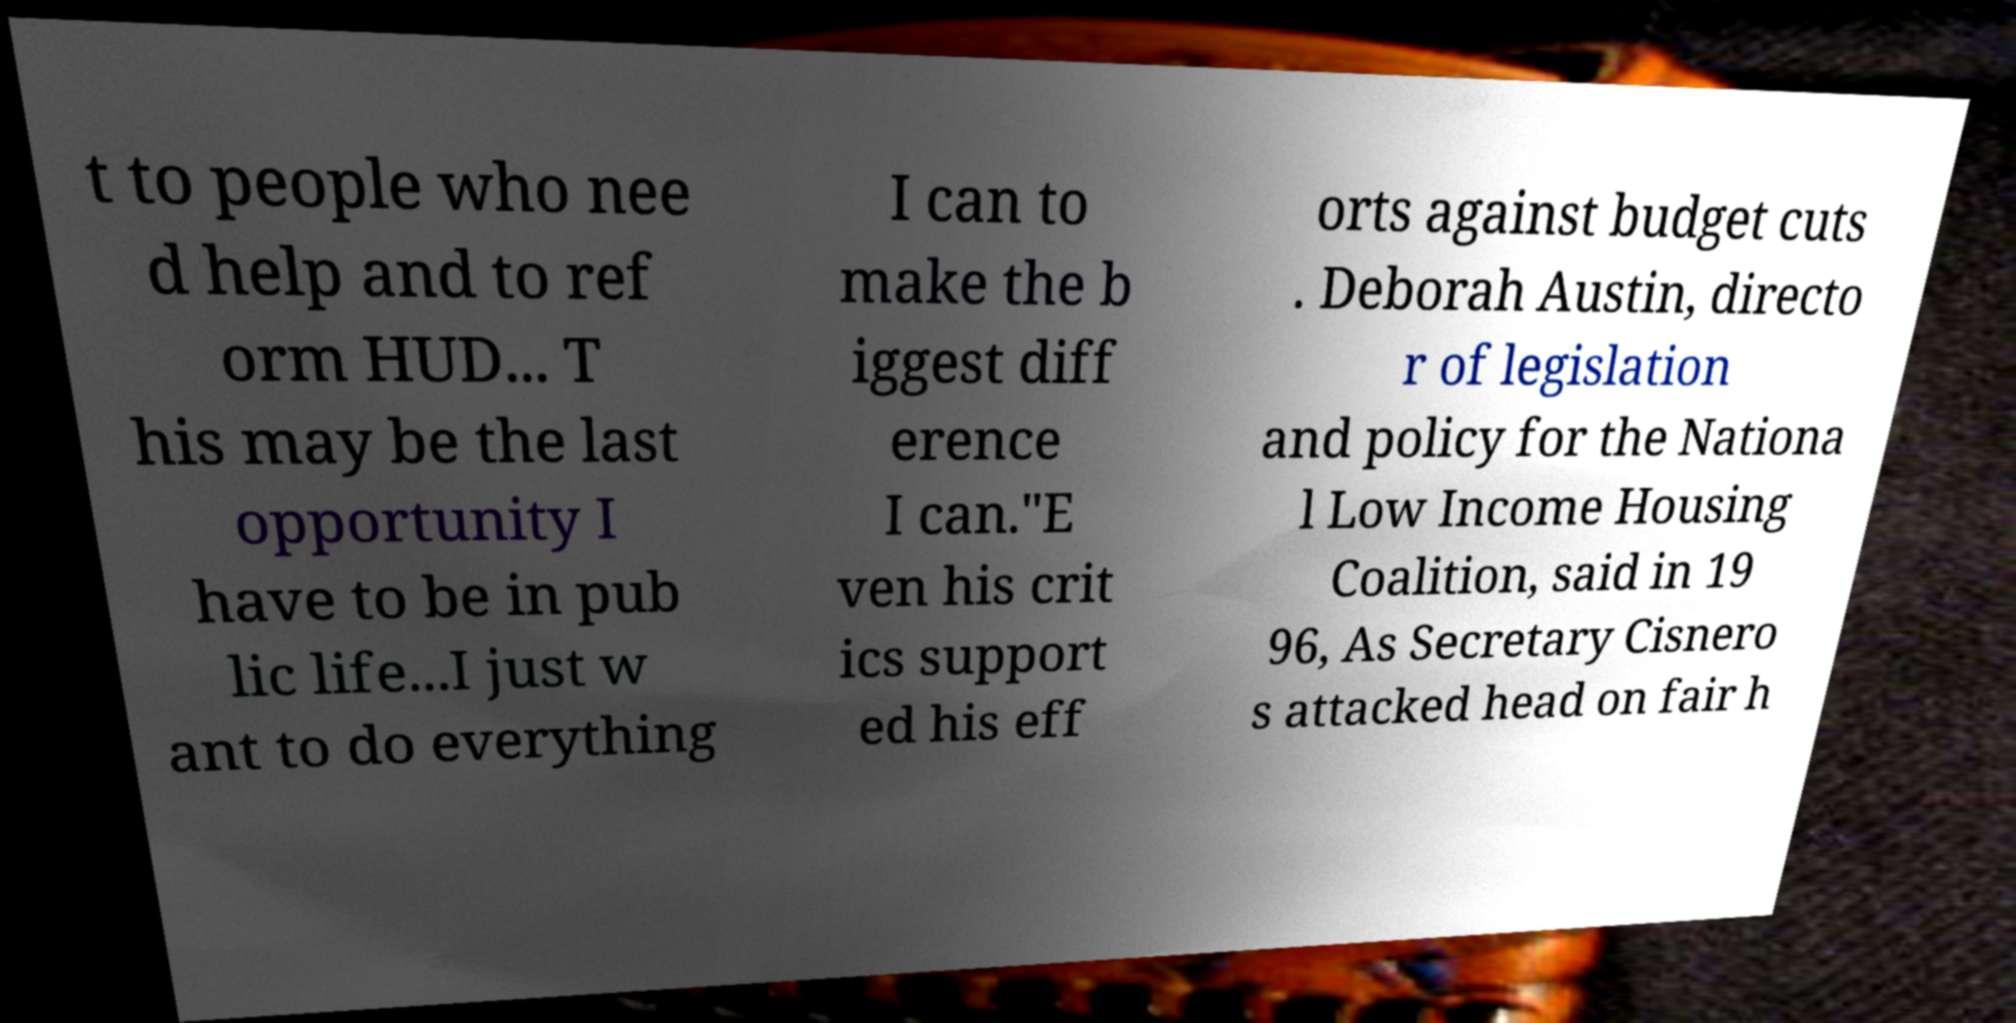Please read and relay the text visible in this image. What does it say? t to people who nee d help and to ref orm HUD... T his may be the last opportunity I have to be in pub lic life...I just w ant to do everything I can to make the b iggest diff erence I can."E ven his crit ics support ed his eff orts against budget cuts . Deborah Austin, directo r of legislation and policy for the Nationa l Low Income Housing Coalition, said in 19 96, As Secretary Cisnero s attacked head on fair h 